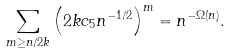Convert formula to latex. <formula><loc_0><loc_0><loc_500><loc_500>\sum _ { m \geq n / 2 k } \left ( 2 k c _ { 5 } n ^ { - 1 / 2 } \right ) ^ { m } = n ^ { - \Omega ( n ) } .</formula> 